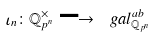Convert formula to latex. <formula><loc_0><loc_0><loc_500><loc_500>\iota _ { n } \colon \mathbb { Q } _ { p ^ { n } } ^ { \times } \longrightarrow \ g a l _ { \mathbb { Q } _ { p ^ { n } } } ^ { a b }</formula> 